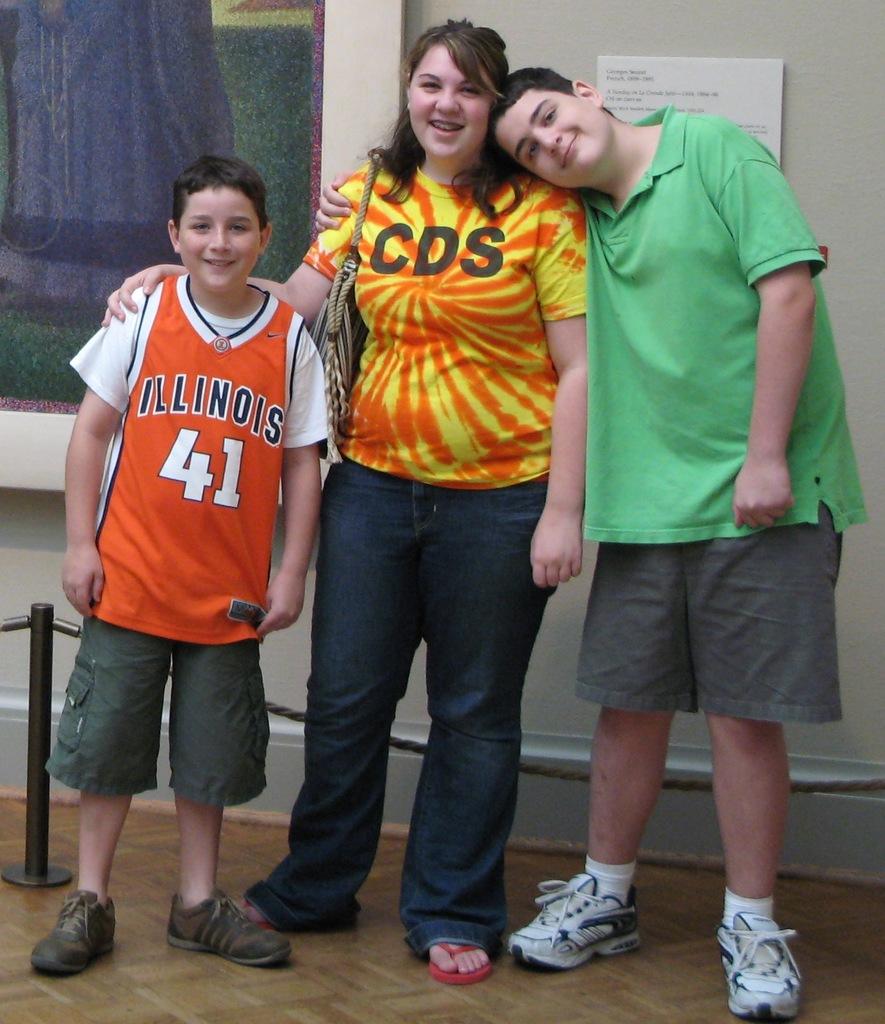What state is on the child's jersey?
Provide a succinct answer. Illinois. What is written on the orange & yellow shirt?
Give a very brief answer. Cds. 